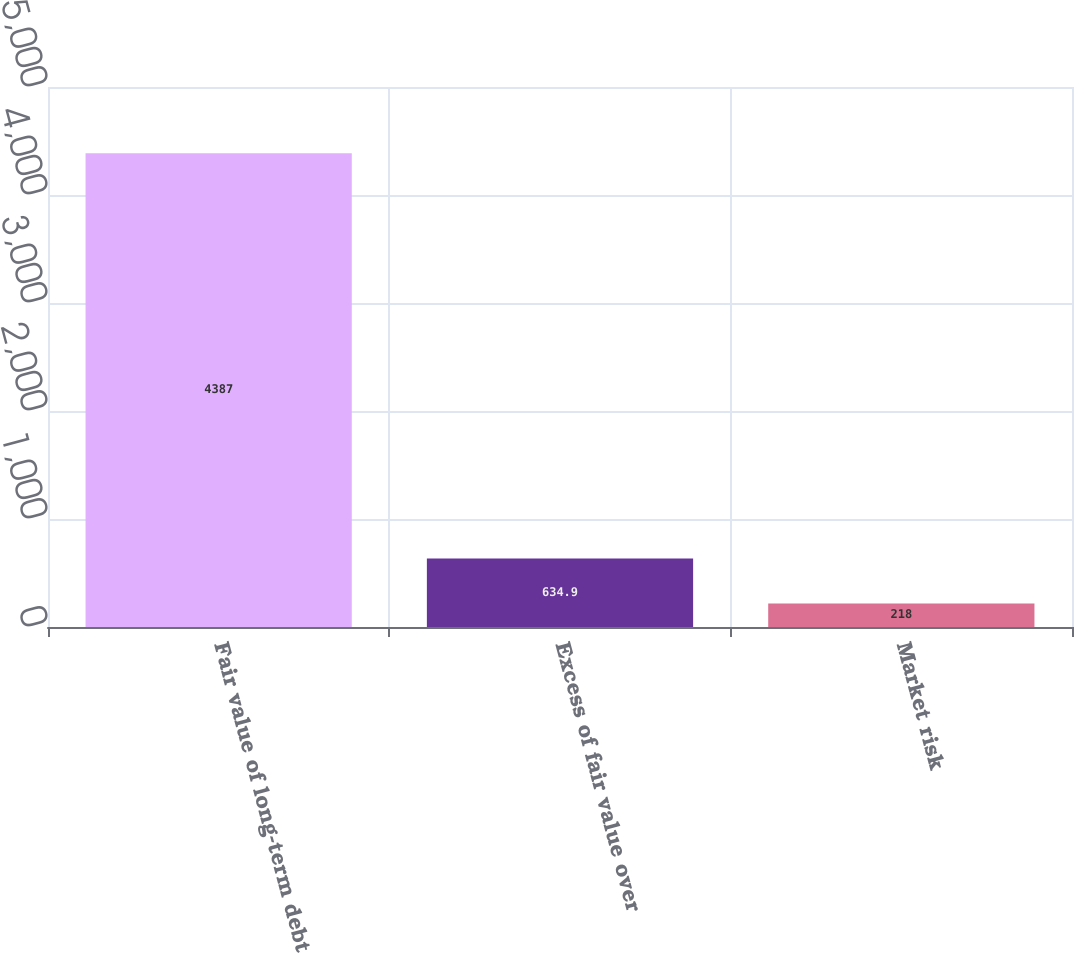Convert chart. <chart><loc_0><loc_0><loc_500><loc_500><bar_chart><fcel>Fair value of long-term debt<fcel>Excess of fair value over<fcel>Market risk<nl><fcel>4387<fcel>634.9<fcel>218<nl></chart> 